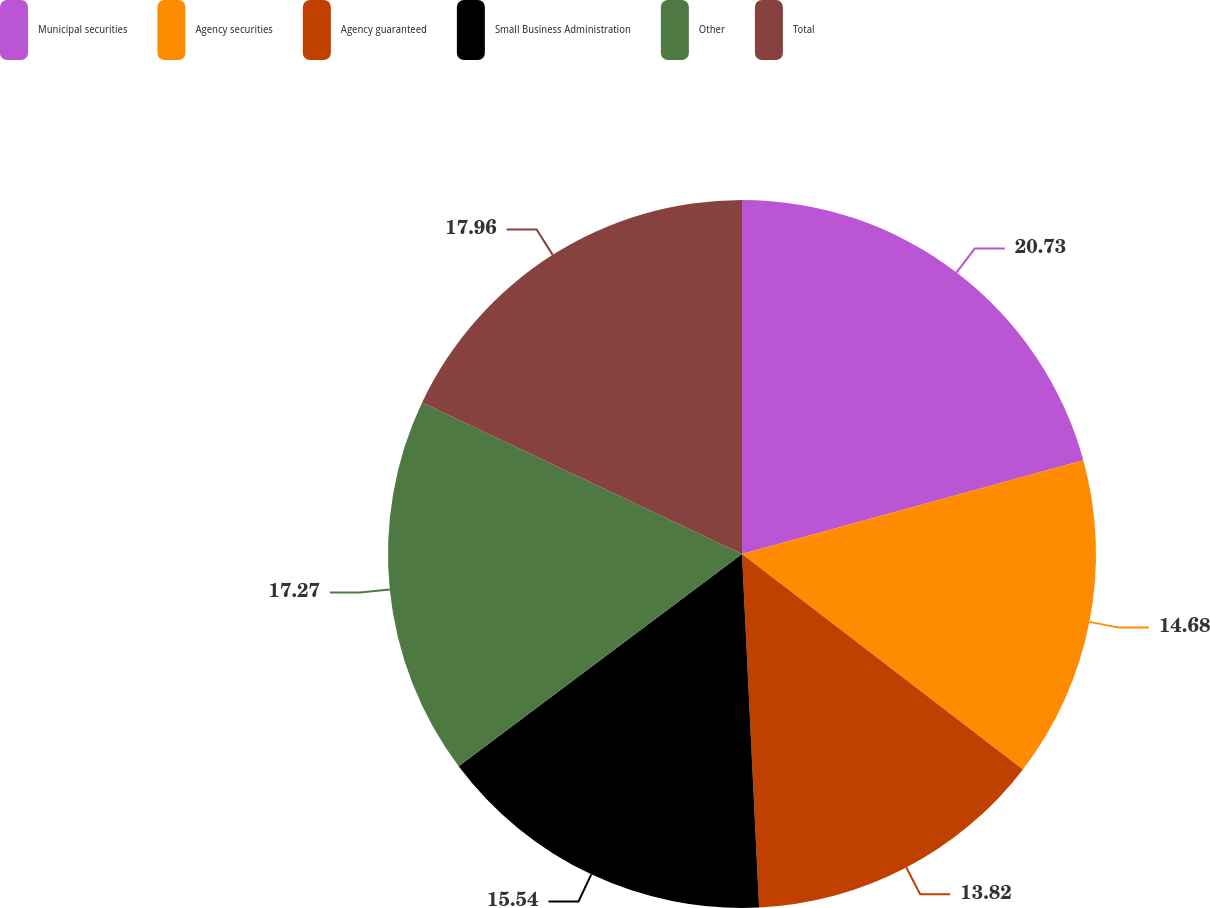Convert chart to OTSL. <chart><loc_0><loc_0><loc_500><loc_500><pie_chart><fcel>Municipal securities<fcel>Agency securities<fcel>Agency guaranteed<fcel>Small Business Administration<fcel>Other<fcel>Total<nl><fcel>20.73%<fcel>14.68%<fcel>13.82%<fcel>15.54%<fcel>17.27%<fcel>17.96%<nl></chart> 